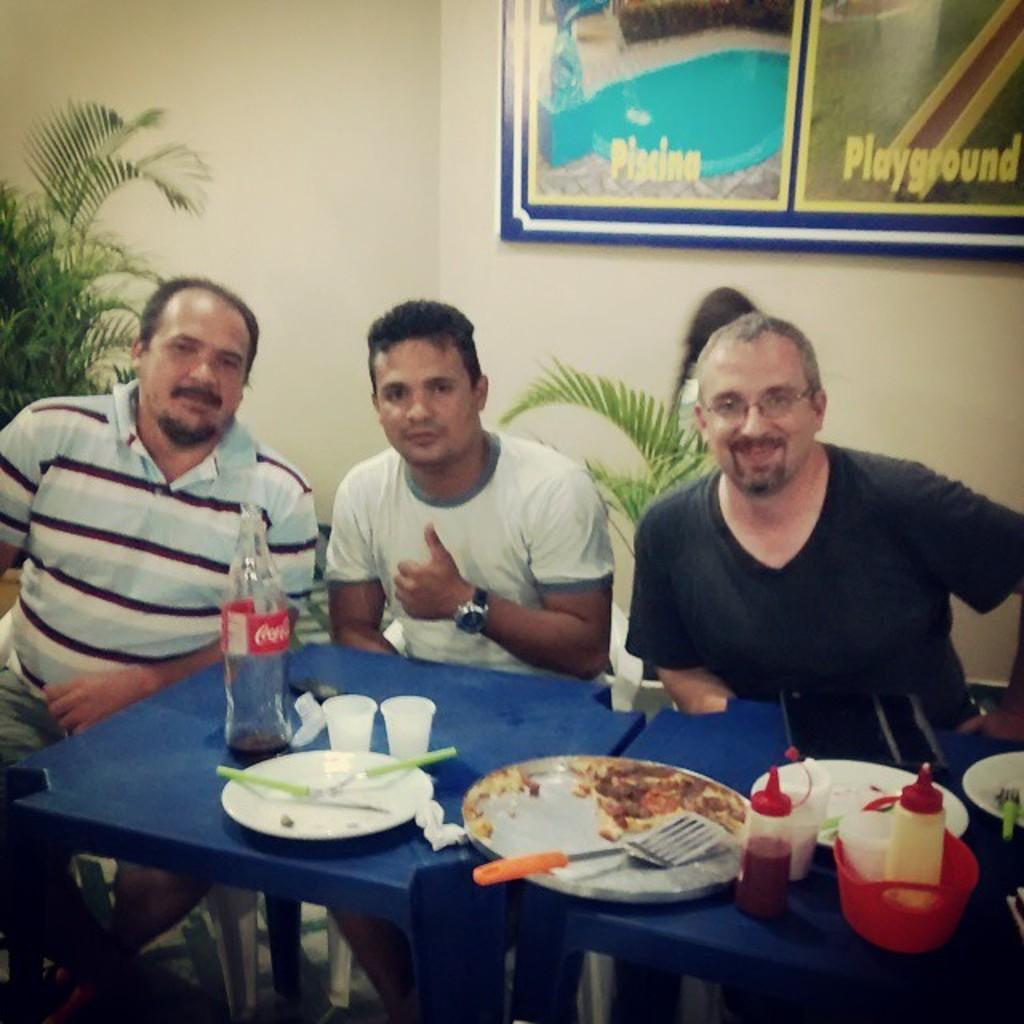Describe this image in one or two sentences. There are three people sitting on chairs,in front of these people we can see plates,spoons,bottles,glasses and objects on tables. In the background we can see plants and board on a wall. 